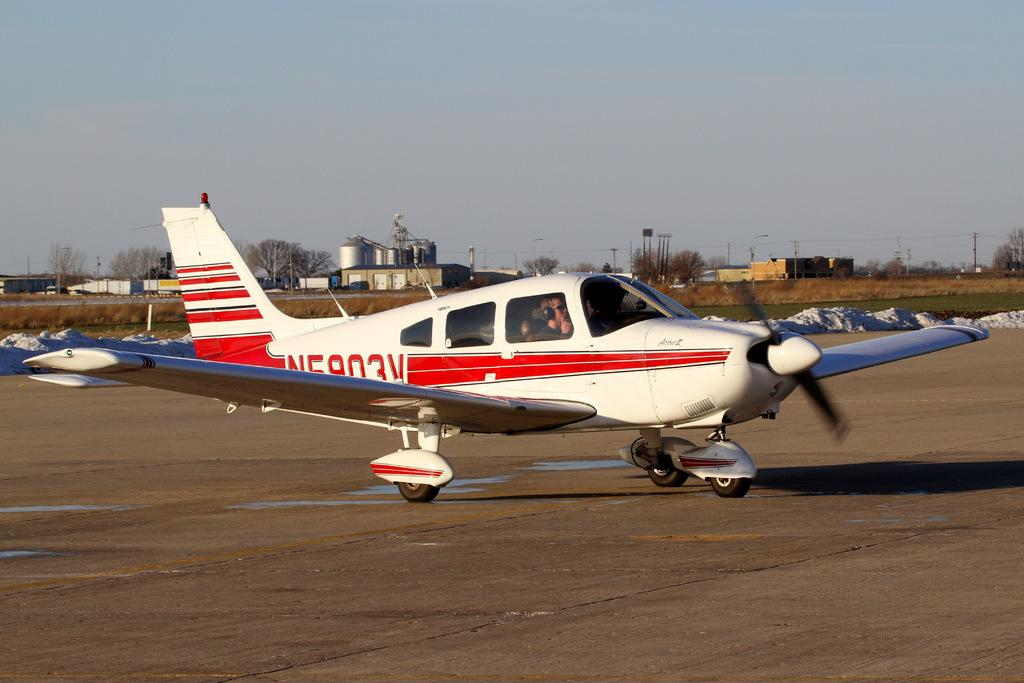<image>
Render a clear and concise summary of the photo. Charter Airplane shown with the label N5903V either taking off or landing. 